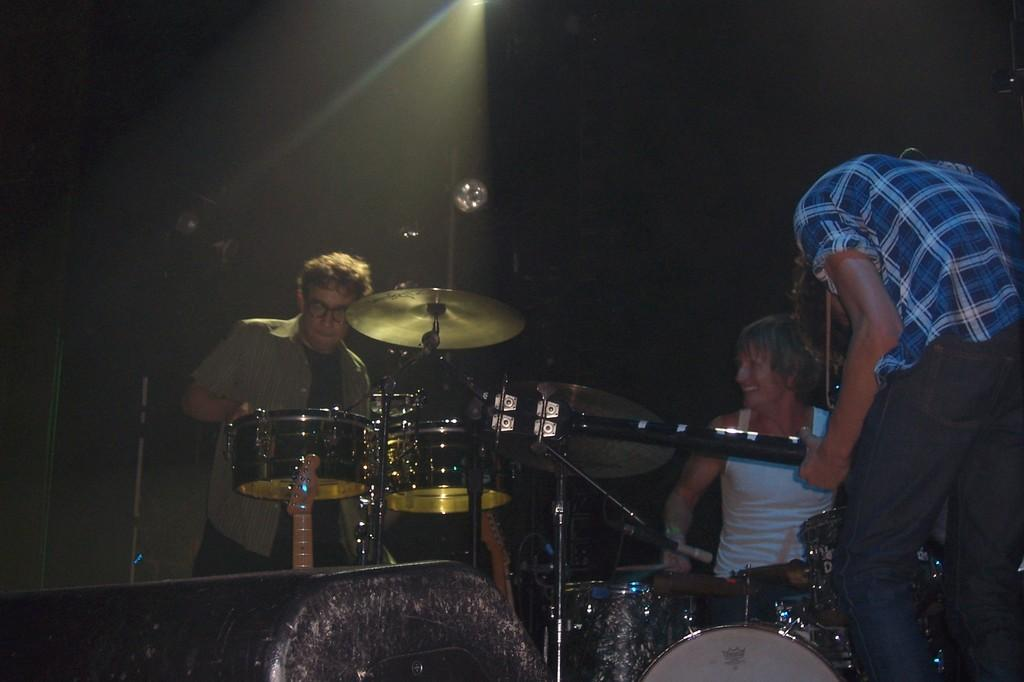How many people are present in the image? There are two persons standing and one person sitting in the image, making a total of three people. What is the person sitting doing in the image? The person sitting is playing a musical instrument. What else can be seen in the image besides the people? There are multiple musical instruments visible in the image. What type of test is being conducted in the image? There is no indication of a test being conducted in the image; it features people and musical instruments. Can you tell me where the hospital is located in the image? There is no hospital present in the image. 